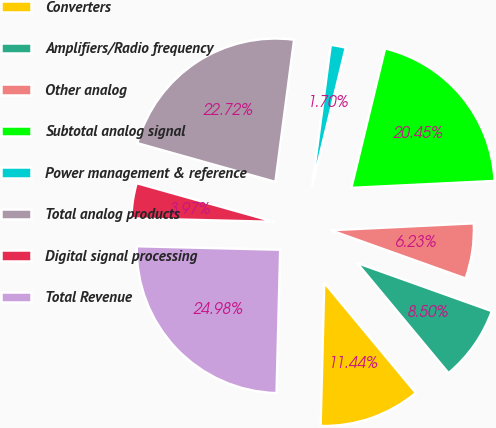<chart> <loc_0><loc_0><loc_500><loc_500><pie_chart><fcel>Converters<fcel>Amplifiers/Radio frequency<fcel>Other analog<fcel>Subtotal analog signal<fcel>Power management & reference<fcel>Total analog products<fcel>Digital signal processing<fcel>Total Revenue<nl><fcel>11.44%<fcel>8.5%<fcel>6.23%<fcel>20.45%<fcel>1.7%<fcel>22.72%<fcel>3.97%<fcel>24.98%<nl></chart> 